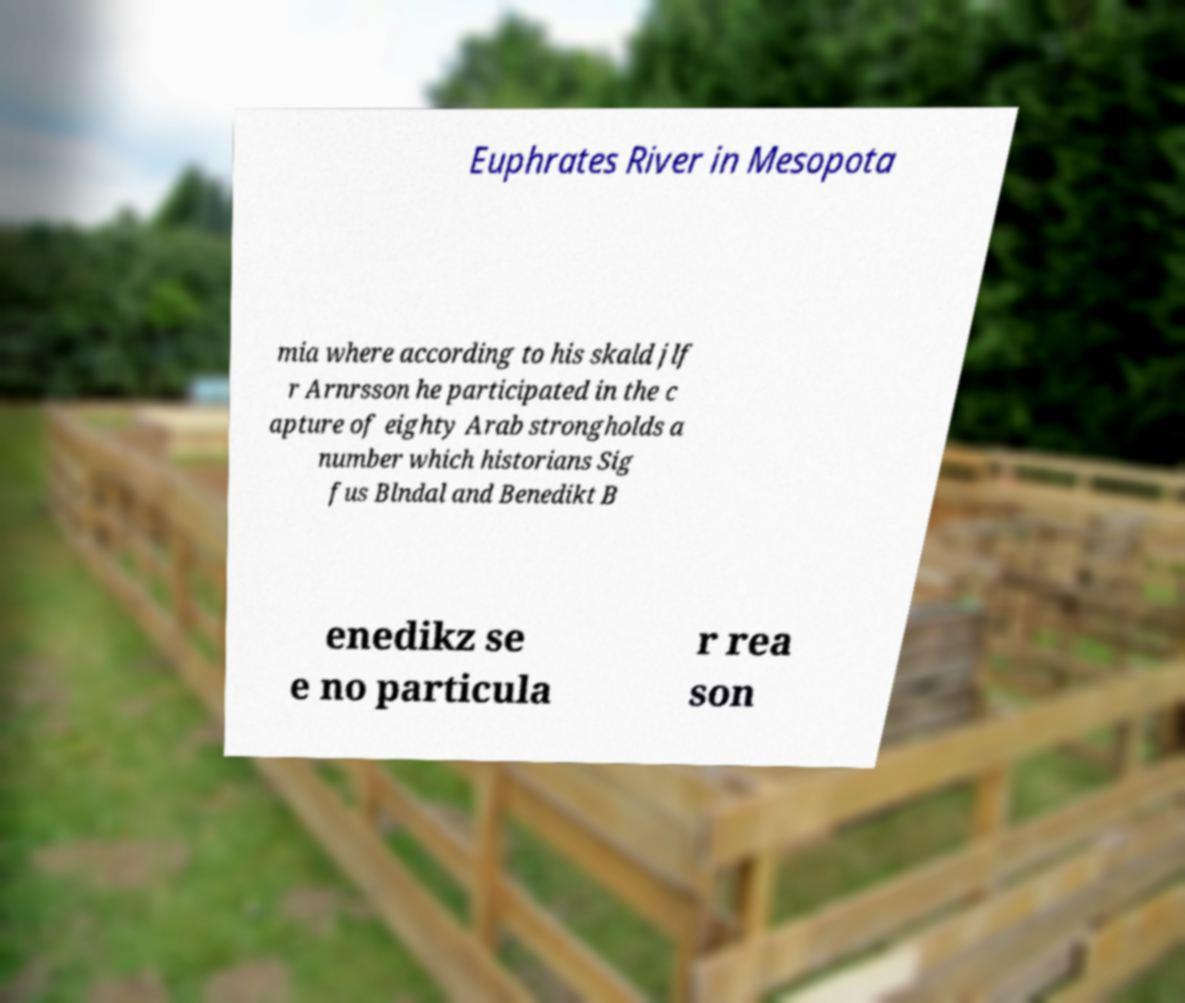Can you read and provide the text displayed in the image?This photo seems to have some interesting text. Can you extract and type it out for me? Euphrates River in Mesopota mia where according to his skald jlf r Arnrsson he participated in the c apture of eighty Arab strongholds a number which historians Sig fus Blndal and Benedikt B enedikz se e no particula r rea son 